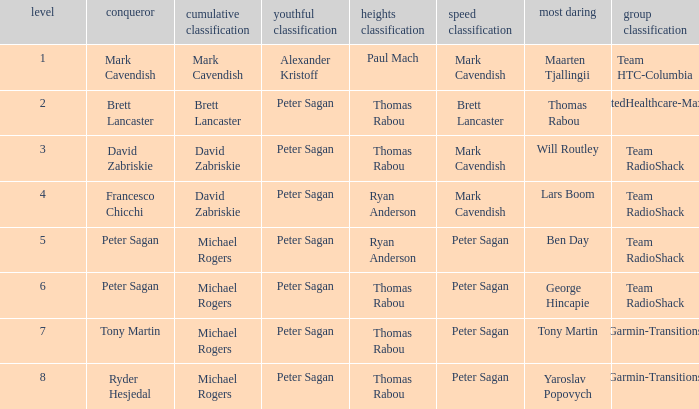When the most courageous honor was given to yaroslav popovych, who came out on top in the mountains classification? Thomas Rabou. 